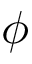Convert formula to latex. <formula><loc_0><loc_0><loc_500><loc_500>\phi</formula> 